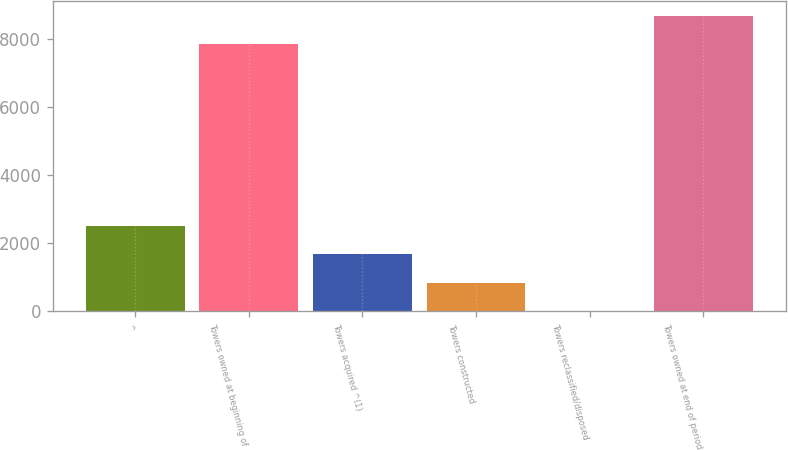<chart> <loc_0><loc_0><loc_500><loc_500><bar_chart><fcel>^<fcel>Towers owned at beginning of<fcel>Towers acquired ^(1)<fcel>Towers constructed<fcel>Towers reclassified/disposed<fcel>Towers owned at end of period<nl><fcel>2502.1<fcel>7854<fcel>1670.4<fcel>838.7<fcel>7<fcel>8685.7<nl></chart> 